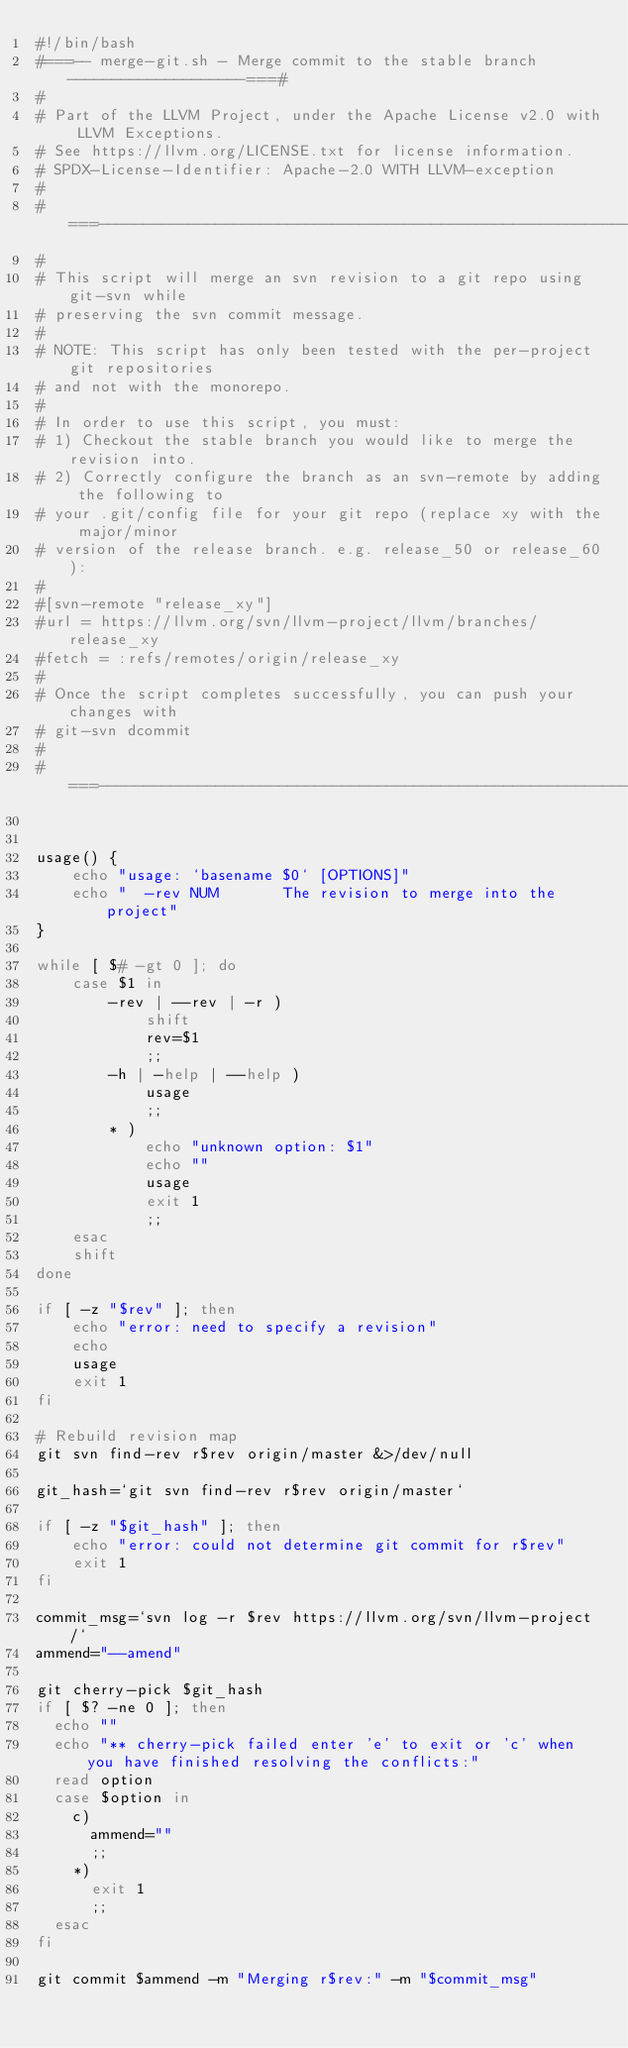Convert code to text. <code><loc_0><loc_0><loc_500><loc_500><_Bash_>#!/bin/bash
#===-- merge-git.sh - Merge commit to the stable branch --------------------===#
#
# Part of the LLVM Project, under the Apache License v2.0 with LLVM Exceptions.
# See https://llvm.org/LICENSE.txt for license information.
# SPDX-License-Identifier: Apache-2.0 WITH LLVM-exception
#
#===------------------------------------------------------------------------===#
#
# This script will merge an svn revision to a git repo using git-svn while
# preserving the svn commit message.
# 
# NOTE: This script has only been tested with the per-project git repositories
# and not with the monorepo.
#
# In order to use this script, you must:
# 1) Checkout the stable branch you would like to merge the revision into.
# 2) Correctly configure the branch as an svn-remote by adding the following to
# your .git/config file for your git repo (replace xy with the major/minor
# version of the release branch. e.g. release_50 or release_60):
#
#[svn-remote "release_xy"]
#url = https://llvm.org/svn/llvm-project/llvm/branches/release_xy
#fetch = :refs/remotes/origin/release_xy
#
# Once the script completes successfully, you can push your changes with
# git-svn dcommit
#
#===------------------------------------------------------------------------===#


usage() {
    echo "usage: `basename $0` [OPTIONS]"
    echo "  -rev NUM       The revision to merge into the project"
}

while [ $# -gt 0 ]; do
    case $1 in
        -rev | --rev | -r )
            shift
            rev=$1
            ;;
        -h | -help | --help )
            usage
            ;;
        * )
            echo "unknown option: $1"
            echo ""
            usage
            exit 1
            ;;
    esac
    shift
done

if [ -z "$rev" ]; then
    echo "error: need to specify a revision"
    echo
    usage
    exit 1
fi

# Rebuild revision map
git svn find-rev r$rev origin/master &>/dev/null

git_hash=`git svn find-rev r$rev origin/master`

if [ -z "$git_hash" ]; then
    echo "error: could not determine git commit for r$rev"
    exit 1
fi

commit_msg=`svn log -r $rev https://llvm.org/svn/llvm-project/`
ammend="--amend"

git cherry-pick $git_hash
if [ $? -ne 0 ]; then
  echo ""
  echo "** cherry-pick failed enter 'e' to exit or 'c' when you have finished resolving the conflicts:"
  read option
  case $option in
    c)
      ammend=""
      ;;
    *)
      exit 1
      ;;
  esac
fi
         
git commit $ammend -m "Merging r$rev:" -m "$commit_msg"
</code> 